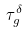Convert formula to latex. <formula><loc_0><loc_0><loc_500><loc_500>\tau _ { g } ^ { \delta }</formula> 